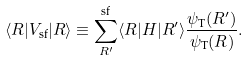<formula> <loc_0><loc_0><loc_500><loc_500>\langle R | V _ { \text {sf} } | R \rangle \equiv \sum _ { R ^ { \prime } } ^ { \text {sf} } \langle R | H | R ^ { \prime } \rangle \frac { \psi _ { \text {T} } ( R ^ { \prime } ) } { \psi _ { \text {T} } ( R ) } .</formula> 